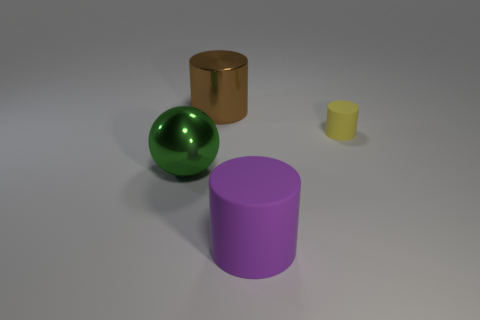How many big matte things are behind the big purple matte thing?
Ensure brevity in your answer.  0. Are there more brown cylinders than large red matte cubes?
Provide a succinct answer. Yes. What size is the object that is in front of the small yellow rubber cylinder and behind the purple matte thing?
Provide a succinct answer. Large. What material is the large cylinder in front of the metal object in front of the metallic object that is right of the large green object?
Make the answer very short. Rubber. Is the color of the rubber object that is behind the big rubber cylinder the same as the thing in front of the large green metallic ball?
Your response must be concise. No. What shape is the object in front of the large metal object that is to the left of the big cylinder on the left side of the purple matte object?
Provide a succinct answer. Cylinder. What shape is the big thing that is both in front of the big brown thing and behind the big purple thing?
Make the answer very short. Sphere. How many large green objects are behind the metallic object that is in front of the rubber object that is on the right side of the purple matte cylinder?
Your answer should be compact. 0. What size is the other matte object that is the same shape as the tiny yellow rubber thing?
Your answer should be very brief. Large. Are there any other things that have the same size as the green metallic object?
Your response must be concise. Yes. 